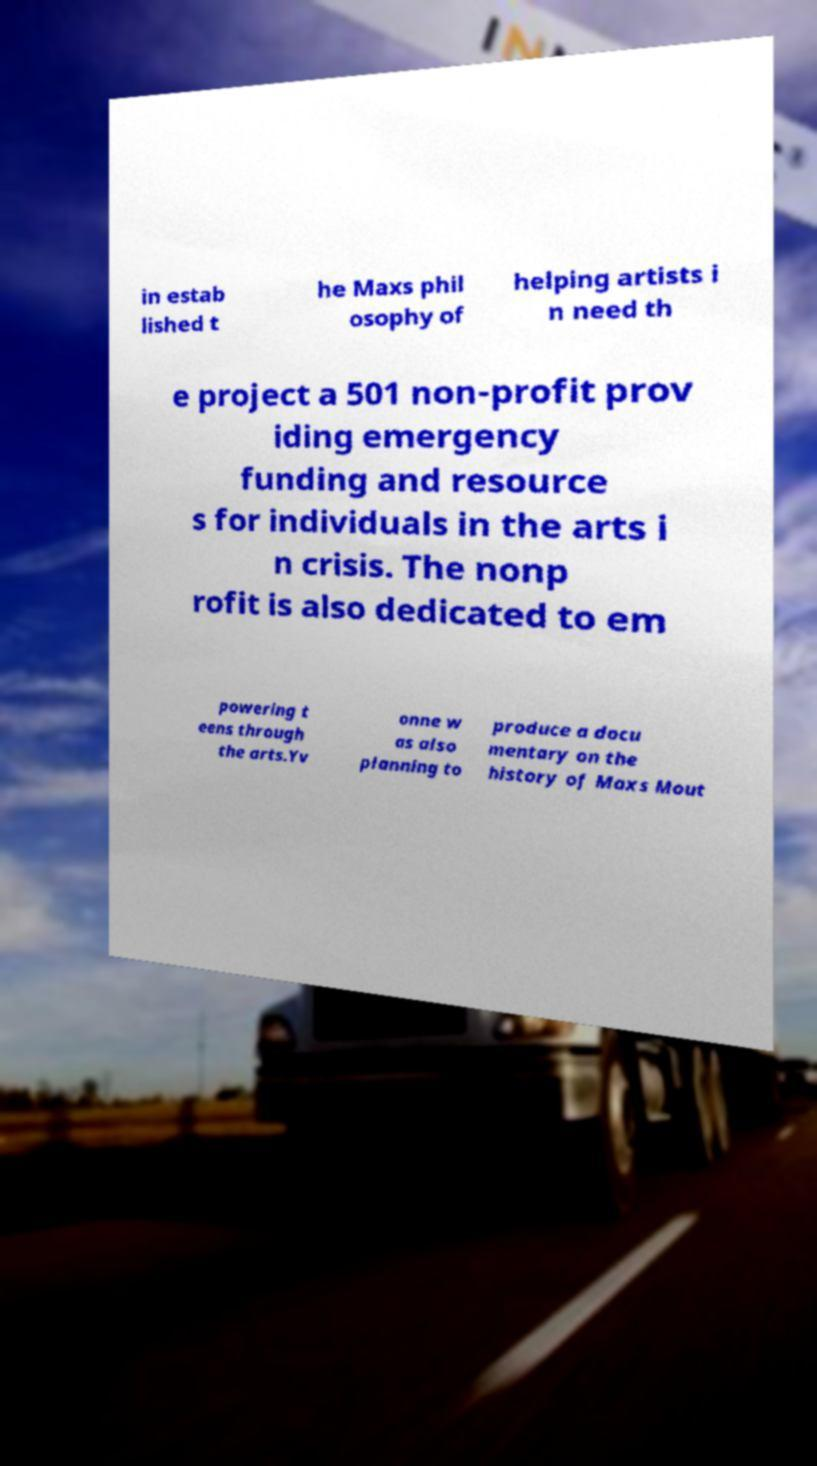Could you assist in decoding the text presented in this image and type it out clearly? in estab lished t he Maxs phil osophy of helping artists i n need th e project a 501 non-profit prov iding emergency funding and resource s for individuals in the arts i n crisis. The nonp rofit is also dedicated to em powering t eens through the arts.Yv onne w as also planning to produce a docu mentary on the history of Maxs Mout 